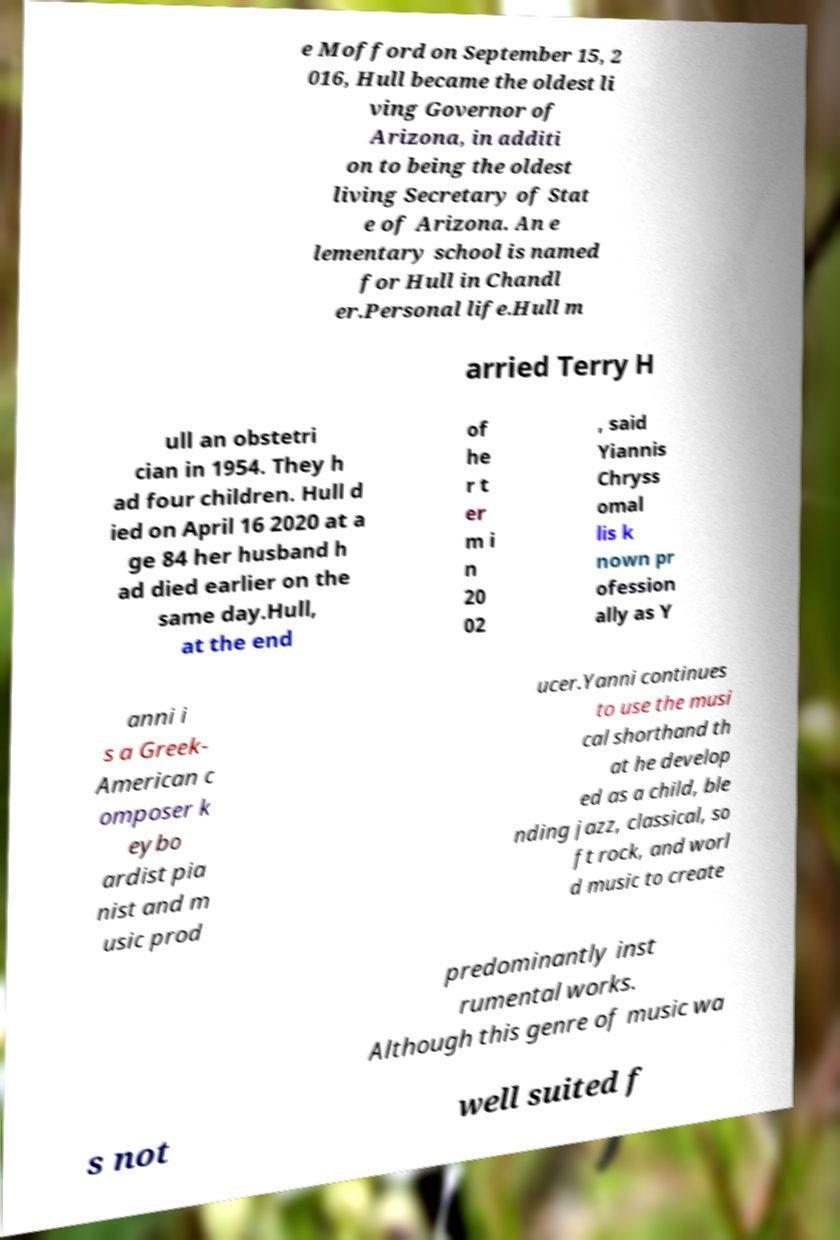Could you assist in decoding the text presented in this image and type it out clearly? e Mofford on September 15, 2 016, Hull became the oldest li ving Governor of Arizona, in additi on to being the oldest living Secretary of Stat e of Arizona. An e lementary school is named for Hull in Chandl er.Personal life.Hull m arried Terry H ull an obstetri cian in 1954. They h ad four children. Hull d ied on April 16 2020 at a ge 84 her husband h ad died earlier on the same day.Hull, at the end of he r t er m i n 20 02 , said Yiannis Chryss omal lis k nown pr ofession ally as Y anni i s a Greek- American c omposer k eybo ardist pia nist and m usic prod ucer.Yanni continues to use the musi cal shorthand th at he develop ed as a child, ble nding jazz, classical, so ft rock, and worl d music to create predominantly inst rumental works. Although this genre of music wa s not well suited f 